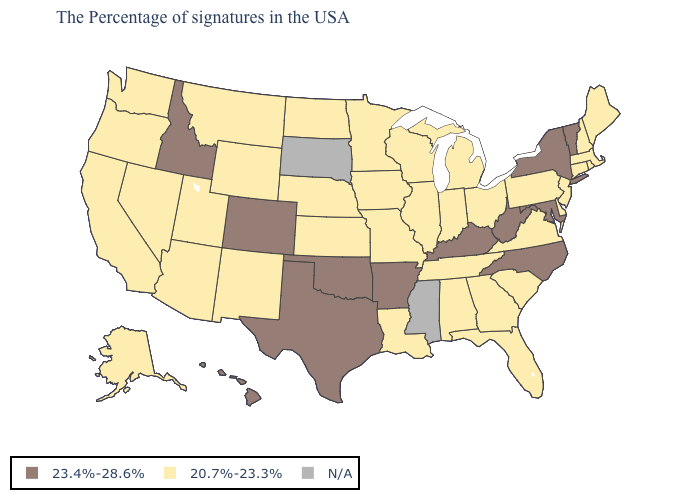What is the highest value in states that border Connecticut?
Concise answer only. 23.4%-28.6%. What is the lowest value in the USA?
Concise answer only. 20.7%-23.3%. Which states have the lowest value in the USA?
Be succinct. Maine, Massachusetts, Rhode Island, New Hampshire, Connecticut, New Jersey, Delaware, Pennsylvania, Virginia, South Carolina, Ohio, Florida, Georgia, Michigan, Indiana, Alabama, Tennessee, Wisconsin, Illinois, Louisiana, Missouri, Minnesota, Iowa, Kansas, Nebraska, North Dakota, Wyoming, New Mexico, Utah, Montana, Arizona, Nevada, California, Washington, Oregon, Alaska. What is the highest value in the USA?
Be succinct. 23.4%-28.6%. Among the states that border Massachusetts , which have the lowest value?
Short answer required. Rhode Island, New Hampshire, Connecticut. What is the highest value in states that border Nebraska?
Quick response, please. 23.4%-28.6%. What is the value of Missouri?
Keep it brief. 20.7%-23.3%. Name the states that have a value in the range 23.4%-28.6%?
Concise answer only. Vermont, New York, Maryland, North Carolina, West Virginia, Kentucky, Arkansas, Oklahoma, Texas, Colorado, Idaho, Hawaii. What is the value of Rhode Island?
Write a very short answer. 20.7%-23.3%. Which states hav the highest value in the MidWest?
Quick response, please. Ohio, Michigan, Indiana, Wisconsin, Illinois, Missouri, Minnesota, Iowa, Kansas, Nebraska, North Dakota. Which states hav the highest value in the MidWest?
Concise answer only. Ohio, Michigan, Indiana, Wisconsin, Illinois, Missouri, Minnesota, Iowa, Kansas, Nebraska, North Dakota. Does Oklahoma have the highest value in the USA?
Keep it brief. Yes. What is the highest value in the West ?
Quick response, please. 23.4%-28.6%. What is the value of North Carolina?
Be succinct. 23.4%-28.6%. 